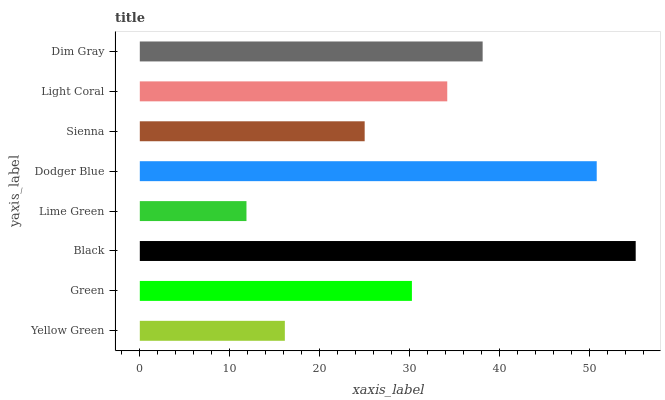Is Lime Green the minimum?
Answer yes or no. Yes. Is Black the maximum?
Answer yes or no. Yes. Is Green the minimum?
Answer yes or no. No. Is Green the maximum?
Answer yes or no. No. Is Green greater than Yellow Green?
Answer yes or no. Yes. Is Yellow Green less than Green?
Answer yes or no. Yes. Is Yellow Green greater than Green?
Answer yes or no. No. Is Green less than Yellow Green?
Answer yes or no. No. Is Light Coral the high median?
Answer yes or no. Yes. Is Green the low median?
Answer yes or no. Yes. Is Dim Gray the high median?
Answer yes or no. No. Is Sienna the low median?
Answer yes or no. No. 